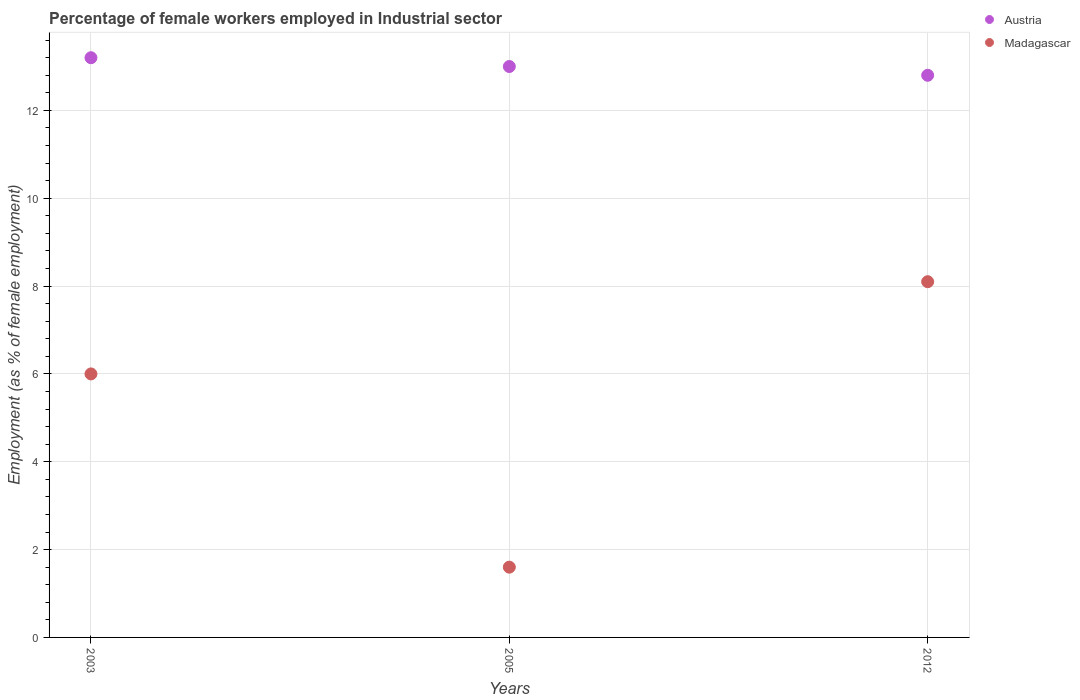How many different coloured dotlines are there?
Offer a terse response. 2. Is the number of dotlines equal to the number of legend labels?
Ensure brevity in your answer.  Yes. What is the percentage of females employed in Industrial sector in Madagascar in 2003?
Provide a short and direct response. 6. Across all years, what is the maximum percentage of females employed in Industrial sector in Madagascar?
Give a very brief answer. 8.1. Across all years, what is the minimum percentage of females employed in Industrial sector in Austria?
Provide a short and direct response. 12.8. In which year was the percentage of females employed in Industrial sector in Austria minimum?
Make the answer very short. 2012. What is the difference between the percentage of females employed in Industrial sector in Austria in 2003 and that in 2005?
Keep it short and to the point. 0.2. What is the difference between the percentage of females employed in Industrial sector in Madagascar in 2003 and the percentage of females employed in Industrial sector in Austria in 2012?
Make the answer very short. -6.8. What is the average percentage of females employed in Industrial sector in Madagascar per year?
Ensure brevity in your answer.  5.23. In the year 2005, what is the difference between the percentage of females employed in Industrial sector in Madagascar and percentage of females employed in Industrial sector in Austria?
Keep it short and to the point. -11.4. In how many years, is the percentage of females employed in Industrial sector in Madagascar greater than 0.8 %?
Your answer should be compact. 3. What is the ratio of the percentage of females employed in Industrial sector in Madagascar in 2003 to that in 2005?
Provide a succinct answer. 3.75. What is the difference between the highest and the second highest percentage of females employed in Industrial sector in Madagascar?
Your answer should be very brief. 2.1. What is the difference between the highest and the lowest percentage of females employed in Industrial sector in Austria?
Provide a succinct answer. 0.4. In how many years, is the percentage of females employed in Industrial sector in Madagascar greater than the average percentage of females employed in Industrial sector in Madagascar taken over all years?
Make the answer very short. 2. Is the percentage of females employed in Industrial sector in Austria strictly greater than the percentage of females employed in Industrial sector in Madagascar over the years?
Offer a very short reply. Yes. Is the percentage of females employed in Industrial sector in Madagascar strictly less than the percentage of females employed in Industrial sector in Austria over the years?
Provide a succinct answer. Yes. How many years are there in the graph?
Offer a very short reply. 3. What is the difference between two consecutive major ticks on the Y-axis?
Keep it short and to the point. 2. Are the values on the major ticks of Y-axis written in scientific E-notation?
Give a very brief answer. No. Does the graph contain any zero values?
Your response must be concise. No. Does the graph contain grids?
Provide a succinct answer. Yes. Where does the legend appear in the graph?
Give a very brief answer. Top right. How many legend labels are there?
Provide a short and direct response. 2. What is the title of the graph?
Your answer should be compact. Percentage of female workers employed in Industrial sector. What is the label or title of the X-axis?
Provide a succinct answer. Years. What is the label or title of the Y-axis?
Your answer should be very brief. Employment (as % of female employment). What is the Employment (as % of female employment) of Austria in 2003?
Your response must be concise. 13.2. What is the Employment (as % of female employment) of Madagascar in 2003?
Make the answer very short. 6. What is the Employment (as % of female employment) of Madagascar in 2005?
Offer a terse response. 1.6. What is the Employment (as % of female employment) in Austria in 2012?
Your answer should be compact. 12.8. What is the Employment (as % of female employment) of Madagascar in 2012?
Make the answer very short. 8.1. Across all years, what is the maximum Employment (as % of female employment) of Austria?
Provide a succinct answer. 13.2. Across all years, what is the maximum Employment (as % of female employment) in Madagascar?
Your answer should be very brief. 8.1. Across all years, what is the minimum Employment (as % of female employment) in Austria?
Your answer should be very brief. 12.8. Across all years, what is the minimum Employment (as % of female employment) in Madagascar?
Your answer should be very brief. 1.6. What is the total Employment (as % of female employment) of Austria in the graph?
Offer a terse response. 39. What is the total Employment (as % of female employment) of Madagascar in the graph?
Offer a very short reply. 15.7. What is the difference between the Employment (as % of female employment) of Austria in 2003 and that in 2012?
Give a very brief answer. 0.4. What is the difference between the Employment (as % of female employment) of Madagascar in 2003 and that in 2012?
Offer a very short reply. -2.1. What is the difference between the Employment (as % of female employment) in Madagascar in 2005 and that in 2012?
Ensure brevity in your answer.  -6.5. What is the difference between the Employment (as % of female employment) of Austria in 2003 and the Employment (as % of female employment) of Madagascar in 2005?
Offer a very short reply. 11.6. What is the difference between the Employment (as % of female employment) of Austria in 2005 and the Employment (as % of female employment) of Madagascar in 2012?
Your answer should be compact. 4.9. What is the average Employment (as % of female employment) of Madagascar per year?
Make the answer very short. 5.23. In the year 2003, what is the difference between the Employment (as % of female employment) of Austria and Employment (as % of female employment) of Madagascar?
Give a very brief answer. 7.2. In the year 2005, what is the difference between the Employment (as % of female employment) in Austria and Employment (as % of female employment) in Madagascar?
Your answer should be very brief. 11.4. What is the ratio of the Employment (as % of female employment) in Austria in 2003 to that in 2005?
Offer a terse response. 1.02. What is the ratio of the Employment (as % of female employment) in Madagascar in 2003 to that in 2005?
Give a very brief answer. 3.75. What is the ratio of the Employment (as % of female employment) of Austria in 2003 to that in 2012?
Make the answer very short. 1.03. What is the ratio of the Employment (as % of female employment) in Madagascar in 2003 to that in 2012?
Your answer should be very brief. 0.74. What is the ratio of the Employment (as % of female employment) of Austria in 2005 to that in 2012?
Offer a terse response. 1.02. What is the ratio of the Employment (as % of female employment) of Madagascar in 2005 to that in 2012?
Keep it short and to the point. 0.2. What is the difference between the highest and the second highest Employment (as % of female employment) of Austria?
Provide a short and direct response. 0.2. What is the difference between the highest and the second highest Employment (as % of female employment) of Madagascar?
Offer a terse response. 2.1. What is the difference between the highest and the lowest Employment (as % of female employment) of Austria?
Keep it short and to the point. 0.4. 